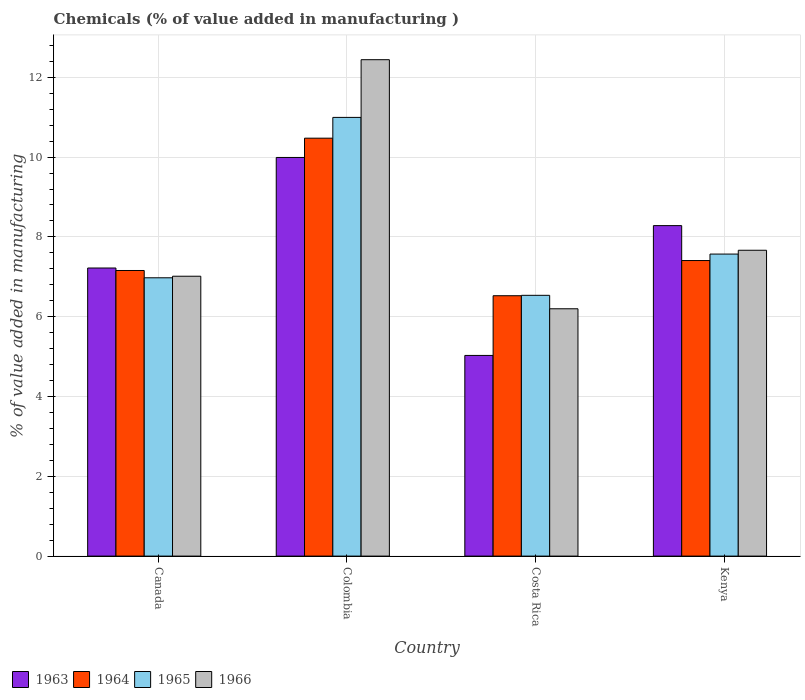How many groups of bars are there?
Provide a short and direct response. 4. Are the number of bars on each tick of the X-axis equal?
Your answer should be compact. Yes. How many bars are there on the 1st tick from the left?
Offer a terse response. 4. How many bars are there on the 1st tick from the right?
Your response must be concise. 4. What is the label of the 3rd group of bars from the left?
Provide a succinct answer. Costa Rica. What is the value added in manufacturing chemicals in 1963 in Canada?
Give a very brief answer. 7.22. Across all countries, what is the maximum value added in manufacturing chemicals in 1966?
Your answer should be very brief. 12.44. Across all countries, what is the minimum value added in manufacturing chemicals in 1963?
Provide a succinct answer. 5.03. In which country was the value added in manufacturing chemicals in 1963 minimum?
Make the answer very short. Costa Rica. What is the total value added in manufacturing chemicals in 1965 in the graph?
Provide a succinct answer. 32.08. What is the difference between the value added in manufacturing chemicals in 1963 in Costa Rica and that in Kenya?
Offer a very short reply. -3.25. What is the difference between the value added in manufacturing chemicals in 1963 in Kenya and the value added in manufacturing chemicals in 1964 in Colombia?
Make the answer very short. -2.19. What is the average value added in manufacturing chemicals in 1963 per country?
Keep it short and to the point. 7.63. What is the difference between the value added in manufacturing chemicals of/in 1963 and value added in manufacturing chemicals of/in 1965 in Kenya?
Provide a succinct answer. 0.71. In how many countries, is the value added in manufacturing chemicals in 1966 greater than 6.4 %?
Offer a terse response. 3. What is the ratio of the value added in manufacturing chemicals in 1963 in Costa Rica to that in Kenya?
Ensure brevity in your answer.  0.61. Is the value added in manufacturing chemicals in 1965 in Costa Rica less than that in Kenya?
Make the answer very short. Yes. What is the difference between the highest and the second highest value added in manufacturing chemicals in 1964?
Provide a succinct answer. 3.32. What is the difference between the highest and the lowest value added in manufacturing chemicals in 1965?
Make the answer very short. 4.46. Is the sum of the value added in manufacturing chemicals in 1965 in Colombia and Costa Rica greater than the maximum value added in manufacturing chemicals in 1964 across all countries?
Offer a very short reply. Yes. What does the 2nd bar from the left in Colombia represents?
Provide a short and direct response. 1964. What does the 1st bar from the right in Colombia represents?
Offer a very short reply. 1966. Is it the case that in every country, the sum of the value added in manufacturing chemicals in 1965 and value added in manufacturing chemicals in 1964 is greater than the value added in manufacturing chemicals in 1966?
Your answer should be very brief. Yes. Are all the bars in the graph horizontal?
Provide a succinct answer. No. What is the difference between two consecutive major ticks on the Y-axis?
Make the answer very short. 2. Does the graph contain any zero values?
Your response must be concise. No. Does the graph contain grids?
Your answer should be compact. Yes. How many legend labels are there?
Ensure brevity in your answer.  4. What is the title of the graph?
Ensure brevity in your answer.  Chemicals (% of value added in manufacturing ). What is the label or title of the X-axis?
Make the answer very short. Country. What is the label or title of the Y-axis?
Offer a very short reply. % of value added in manufacturing. What is the % of value added in manufacturing of 1963 in Canada?
Your answer should be very brief. 7.22. What is the % of value added in manufacturing in 1964 in Canada?
Your answer should be compact. 7.16. What is the % of value added in manufacturing in 1965 in Canada?
Your answer should be compact. 6.98. What is the % of value added in manufacturing of 1966 in Canada?
Keep it short and to the point. 7.01. What is the % of value added in manufacturing in 1963 in Colombia?
Provide a short and direct response. 9.99. What is the % of value added in manufacturing in 1964 in Colombia?
Ensure brevity in your answer.  10.47. What is the % of value added in manufacturing of 1965 in Colombia?
Offer a terse response. 10.99. What is the % of value added in manufacturing of 1966 in Colombia?
Give a very brief answer. 12.44. What is the % of value added in manufacturing in 1963 in Costa Rica?
Ensure brevity in your answer.  5.03. What is the % of value added in manufacturing in 1964 in Costa Rica?
Keep it short and to the point. 6.53. What is the % of value added in manufacturing of 1965 in Costa Rica?
Ensure brevity in your answer.  6.54. What is the % of value added in manufacturing in 1966 in Costa Rica?
Make the answer very short. 6.2. What is the % of value added in manufacturing in 1963 in Kenya?
Your answer should be compact. 8.28. What is the % of value added in manufacturing in 1964 in Kenya?
Your answer should be compact. 7.41. What is the % of value added in manufacturing in 1965 in Kenya?
Offer a terse response. 7.57. What is the % of value added in manufacturing of 1966 in Kenya?
Your response must be concise. 7.67. Across all countries, what is the maximum % of value added in manufacturing of 1963?
Make the answer very short. 9.99. Across all countries, what is the maximum % of value added in manufacturing of 1964?
Offer a terse response. 10.47. Across all countries, what is the maximum % of value added in manufacturing in 1965?
Ensure brevity in your answer.  10.99. Across all countries, what is the maximum % of value added in manufacturing in 1966?
Offer a very short reply. 12.44. Across all countries, what is the minimum % of value added in manufacturing of 1963?
Your answer should be very brief. 5.03. Across all countries, what is the minimum % of value added in manufacturing of 1964?
Offer a terse response. 6.53. Across all countries, what is the minimum % of value added in manufacturing in 1965?
Give a very brief answer. 6.54. Across all countries, what is the minimum % of value added in manufacturing of 1966?
Make the answer very short. 6.2. What is the total % of value added in manufacturing in 1963 in the graph?
Provide a succinct answer. 30.52. What is the total % of value added in manufacturing of 1964 in the graph?
Your answer should be very brief. 31.57. What is the total % of value added in manufacturing of 1965 in the graph?
Your answer should be compact. 32.08. What is the total % of value added in manufacturing of 1966 in the graph?
Make the answer very short. 33.32. What is the difference between the % of value added in manufacturing in 1963 in Canada and that in Colombia?
Offer a terse response. -2.77. What is the difference between the % of value added in manufacturing in 1964 in Canada and that in Colombia?
Give a very brief answer. -3.32. What is the difference between the % of value added in manufacturing of 1965 in Canada and that in Colombia?
Your answer should be compact. -4.02. What is the difference between the % of value added in manufacturing of 1966 in Canada and that in Colombia?
Provide a succinct answer. -5.43. What is the difference between the % of value added in manufacturing in 1963 in Canada and that in Costa Rica?
Make the answer very short. 2.19. What is the difference between the % of value added in manufacturing in 1964 in Canada and that in Costa Rica?
Give a very brief answer. 0.63. What is the difference between the % of value added in manufacturing of 1965 in Canada and that in Costa Rica?
Your answer should be very brief. 0.44. What is the difference between the % of value added in manufacturing of 1966 in Canada and that in Costa Rica?
Provide a succinct answer. 0.82. What is the difference between the % of value added in manufacturing of 1963 in Canada and that in Kenya?
Provide a short and direct response. -1.06. What is the difference between the % of value added in manufacturing in 1964 in Canada and that in Kenya?
Give a very brief answer. -0.25. What is the difference between the % of value added in manufacturing of 1965 in Canada and that in Kenya?
Offer a terse response. -0.59. What is the difference between the % of value added in manufacturing of 1966 in Canada and that in Kenya?
Keep it short and to the point. -0.65. What is the difference between the % of value added in manufacturing of 1963 in Colombia and that in Costa Rica?
Your response must be concise. 4.96. What is the difference between the % of value added in manufacturing in 1964 in Colombia and that in Costa Rica?
Your answer should be very brief. 3.95. What is the difference between the % of value added in manufacturing in 1965 in Colombia and that in Costa Rica?
Your answer should be very brief. 4.46. What is the difference between the % of value added in manufacturing of 1966 in Colombia and that in Costa Rica?
Provide a succinct answer. 6.24. What is the difference between the % of value added in manufacturing in 1963 in Colombia and that in Kenya?
Offer a terse response. 1.71. What is the difference between the % of value added in manufacturing in 1964 in Colombia and that in Kenya?
Your answer should be very brief. 3.07. What is the difference between the % of value added in manufacturing of 1965 in Colombia and that in Kenya?
Ensure brevity in your answer.  3.43. What is the difference between the % of value added in manufacturing of 1966 in Colombia and that in Kenya?
Provide a short and direct response. 4.78. What is the difference between the % of value added in manufacturing in 1963 in Costa Rica and that in Kenya?
Provide a succinct answer. -3.25. What is the difference between the % of value added in manufacturing of 1964 in Costa Rica and that in Kenya?
Ensure brevity in your answer.  -0.88. What is the difference between the % of value added in manufacturing in 1965 in Costa Rica and that in Kenya?
Give a very brief answer. -1.03. What is the difference between the % of value added in manufacturing of 1966 in Costa Rica and that in Kenya?
Your answer should be compact. -1.47. What is the difference between the % of value added in manufacturing in 1963 in Canada and the % of value added in manufacturing in 1964 in Colombia?
Provide a short and direct response. -3.25. What is the difference between the % of value added in manufacturing in 1963 in Canada and the % of value added in manufacturing in 1965 in Colombia?
Your response must be concise. -3.77. What is the difference between the % of value added in manufacturing of 1963 in Canada and the % of value added in manufacturing of 1966 in Colombia?
Keep it short and to the point. -5.22. What is the difference between the % of value added in manufacturing in 1964 in Canada and the % of value added in manufacturing in 1965 in Colombia?
Give a very brief answer. -3.84. What is the difference between the % of value added in manufacturing in 1964 in Canada and the % of value added in manufacturing in 1966 in Colombia?
Provide a succinct answer. -5.28. What is the difference between the % of value added in manufacturing in 1965 in Canada and the % of value added in manufacturing in 1966 in Colombia?
Provide a succinct answer. -5.47. What is the difference between the % of value added in manufacturing in 1963 in Canada and the % of value added in manufacturing in 1964 in Costa Rica?
Make the answer very short. 0.69. What is the difference between the % of value added in manufacturing of 1963 in Canada and the % of value added in manufacturing of 1965 in Costa Rica?
Provide a succinct answer. 0.68. What is the difference between the % of value added in manufacturing in 1963 in Canada and the % of value added in manufacturing in 1966 in Costa Rica?
Give a very brief answer. 1.02. What is the difference between the % of value added in manufacturing of 1964 in Canada and the % of value added in manufacturing of 1965 in Costa Rica?
Make the answer very short. 0.62. What is the difference between the % of value added in manufacturing of 1964 in Canada and the % of value added in manufacturing of 1966 in Costa Rica?
Your answer should be very brief. 0.96. What is the difference between the % of value added in manufacturing of 1965 in Canada and the % of value added in manufacturing of 1966 in Costa Rica?
Offer a terse response. 0.78. What is the difference between the % of value added in manufacturing in 1963 in Canada and the % of value added in manufacturing in 1964 in Kenya?
Keep it short and to the point. -0.19. What is the difference between the % of value added in manufacturing of 1963 in Canada and the % of value added in manufacturing of 1965 in Kenya?
Your response must be concise. -0.35. What is the difference between the % of value added in manufacturing in 1963 in Canada and the % of value added in manufacturing in 1966 in Kenya?
Keep it short and to the point. -0.44. What is the difference between the % of value added in manufacturing of 1964 in Canada and the % of value added in manufacturing of 1965 in Kenya?
Offer a terse response. -0.41. What is the difference between the % of value added in manufacturing of 1964 in Canada and the % of value added in manufacturing of 1966 in Kenya?
Your response must be concise. -0.51. What is the difference between the % of value added in manufacturing in 1965 in Canada and the % of value added in manufacturing in 1966 in Kenya?
Your answer should be compact. -0.69. What is the difference between the % of value added in manufacturing of 1963 in Colombia and the % of value added in manufacturing of 1964 in Costa Rica?
Your answer should be compact. 3.47. What is the difference between the % of value added in manufacturing of 1963 in Colombia and the % of value added in manufacturing of 1965 in Costa Rica?
Your response must be concise. 3.46. What is the difference between the % of value added in manufacturing in 1963 in Colombia and the % of value added in manufacturing in 1966 in Costa Rica?
Your response must be concise. 3.79. What is the difference between the % of value added in manufacturing of 1964 in Colombia and the % of value added in manufacturing of 1965 in Costa Rica?
Offer a very short reply. 3.94. What is the difference between the % of value added in manufacturing in 1964 in Colombia and the % of value added in manufacturing in 1966 in Costa Rica?
Your answer should be very brief. 4.28. What is the difference between the % of value added in manufacturing in 1965 in Colombia and the % of value added in manufacturing in 1966 in Costa Rica?
Provide a short and direct response. 4.8. What is the difference between the % of value added in manufacturing in 1963 in Colombia and the % of value added in manufacturing in 1964 in Kenya?
Keep it short and to the point. 2.58. What is the difference between the % of value added in manufacturing in 1963 in Colombia and the % of value added in manufacturing in 1965 in Kenya?
Your answer should be compact. 2.42. What is the difference between the % of value added in manufacturing in 1963 in Colombia and the % of value added in manufacturing in 1966 in Kenya?
Offer a terse response. 2.33. What is the difference between the % of value added in manufacturing of 1964 in Colombia and the % of value added in manufacturing of 1965 in Kenya?
Your response must be concise. 2.9. What is the difference between the % of value added in manufacturing of 1964 in Colombia and the % of value added in manufacturing of 1966 in Kenya?
Provide a succinct answer. 2.81. What is the difference between the % of value added in manufacturing in 1965 in Colombia and the % of value added in manufacturing in 1966 in Kenya?
Your answer should be compact. 3.33. What is the difference between the % of value added in manufacturing of 1963 in Costa Rica and the % of value added in manufacturing of 1964 in Kenya?
Keep it short and to the point. -2.38. What is the difference between the % of value added in manufacturing of 1963 in Costa Rica and the % of value added in manufacturing of 1965 in Kenya?
Provide a succinct answer. -2.54. What is the difference between the % of value added in manufacturing in 1963 in Costa Rica and the % of value added in manufacturing in 1966 in Kenya?
Your answer should be compact. -2.64. What is the difference between the % of value added in manufacturing of 1964 in Costa Rica and the % of value added in manufacturing of 1965 in Kenya?
Your answer should be very brief. -1.04. What is the difference between the % of value added in manufacturing of 1964 in Costa Rica and the % of value added in manufacturing of 1966 in Kenya?
Provide a succinct answer. -1.14. What is the difference between the % of value added in manufacturing in 1965 in Costa Rica and the % of value added in manufacturing in 1966 in Kenya?
Keep it short and to the point. -1.13. What is the average % of value added in manufacturing of 1963 per country?
Provide a succinct answer. 7.63. What is the average % of value added in manufacturing in 1964 per country?
Provide a short and direct response. 7.89. What is the average % of value added in manufacturing in 1965 per country?
Offer a terse response. 8.02. What is the average % of value added in manufacturing of 1966 per country?
Your answer should be very brief. 8.33. What is the difference between the % of value added in manufacturing of 1963 and % of value added in manufacturing of 1964 in Canada?
Ensure brevity in your answer.  0.06. What is the difference between the % of value added in manufacturing in 1963 and % of value added in manufacturing in 1965 in Canada?
Give a very brief answer. 0.25. What is the difference between the % of value added in manufacturing in 1963 and % of value added in manufacturing in 1966 in Canada?
Keep it short and to the point. 0.21. What is the difference between the % of value added in manufacturing in 1964 and % of value added in manufacturing in 1965 in Canada?
Ensure brevity in your answer.  0.18. What is the difference between the % of value added in manufacturing of 1964 and % of value added in manufacturing of 1966 in Canada?
Offer a very short reply. 0.14. What is the difference between the % of value added in manufacturing in 1965 and % of value added in manufacturing in 1966 in Canada?
Your answer should be very brief. -0.04. What is the difference between the % of value added in manufacturing in 1963 and % of value added in manufacturing in 1964 in Colombia?
Provide a short and direct response. -0.48. What is the difference between the % of value added in manufacturing in 1963 and % of value added in manufacturing in 1965 in Colombia?
Make the answer very short. -1. What is the difference between the % of value added in manufacturing of 1963 and % of value added in manufacturing of 1966 in Colombia?
Provide a short and direct response. -2.45. What is the difference between the % of value added in manufacturing in 1964 and % of value added in manufacturing in 1965 in Colombia?
Ensure brevity in your answer.  -0.52. What is the difference between the % of value added in manufacturing of 1964 and % of value added in manufacturing of 1966 in Colombia?
Give a very brief answer. -1.97. What is the difference between the % of value added in manufacturing in 1965 and % of value added in manufacturing in 1966 in Colombia?
Keep it short and to the point. -1.45. What is the difference between the % of value added in manufacturing of 1963 and % of value added in manufacturing of 1964 in Costa Rica?
Your response must be concise. -1.5. What is the difference between the % of value added in manufacturing of 1963 and % of value added in manufacturing of 1965 in Costa Rica?
Give a very brief answer. -1.51. What is the difference between the % of value added in manufacturing of 1963 and % of value added in manufacturing of 1966 in Costa Rica?
Give a very brief answer. -1.17. What is the difference between the % of value added in manufacturing of 1964 and % of value added in manufacturing of 1965 in Costa Rica?
Keep it short and to the point. -0.01. What is the difference between the % of value added in manufacturing in 1964 and % of value added in manufacturing in 1966 in Costa Rica?
Make the answer very short. 0.33. What is the difference between the % of value added in manufacturing in 1965 and % of value added in manufacturing in 1966 in Costa Rica?
Ensure brevity in your answer.  0.34. What is the difference between the % of value added in manufacturing of 1963 and % of value added in manufacturing of 1964 in Kenya?
Offer a very short reply. 0.87. What is the difference between the % of value added in manufacturing in 1963 and % of value added in manufacturing in 1965 in Kenya?
Offer a very short reply. 0.71. What is the difference between the % of value added in manufacturing of 1963 and % of value added in manufacturing of 1966 in Kenya?
Your response must be concise. 0.62. What is the difference between the % of value added in manufacturing in 1964 and % of value added in manufacturing in 1965 in Kenya?
Keep it short and to the point. -0.16. What is the difference between the % of value added in manufacturing of 1964 and % of value added in manufacturing of 1966 in Kenya?
Give a very brief answer. -0.26. What is the difference between the % of value added in manufacturing in 1965 and % of value added in manufacturing in 1966 in Kenya?
Make the answer very short. -0.1. What is the ratio of the % of value added in manufacturing in 1963 in Canada to that in Colombia?
Ensure brevity in your answer.  0.72. What is the ratio of the % of value added in manufacturing in 1964 in Canada to that in Colombia?
Provide a succinct answer. 0.68. What is the ratio of the % of value added in manufacturing in 1965 in Canada to that in Colombia?
Your answer should be very brief. 0.63. What is the ratio of the % of value added in manufacturing in 1966 in Canada to that in Colombia?
Your answer should be very brief. 0.56. What is the ratio of the % of value added in manufacturing in 1963 in Canada to that in Costa Rica?
Your answer should be compact. 1.44. What is the ratio of the % of value added in manufacturing of 1964 in Canada to that in Costa Rica?
Your answer should be very brief. 1.1. What is the ratio of the % of value added in manufacturing of 1965 in Canada to that in Costa Rica?
Your answer should be compact. 1.07. What is the ratio of the % of value added in manufacturing in 1966 in Canada to that in Costa Rica?
Your response must be concise. 1.13. What is the ratio of the % of value added in manufacturing in 1963 in Canada to that in Kenya?
Your answer should be compact. 0.87. What is the ratio of the % of value added in manufacturing of 1964 in Canada to that in Kenya?
Provide a succinct answer. 0.97. What is the ratio of the % of value added in manufacturing of 1965 in Canada to that in Kenya?
Ensure brevity in your answer.  0.92. What is the ratio of the % of value added in manufacturing in 1966 in Canada to that in Kenya?
Keep it short and to the point. 0.92. What is the ratio of the % of value added in manufacturing of 1963 in Colombia to that in Costa Rica?
Offer a very short reply. 1.99. What is the ratio of the % of value added in manufacturing of 1964 in Colombia to that in Costa Rica?
Offer a terse response. 1.61. What is the ratio of the % of value added in manufacturing in 1965 in Colombia to that in Costa Rica?
Offer a terse response. 1.68. What is the ratio of the % of value added in manufacturing of 1966 in Colombia to that in Costa Rica?
Ensure brevity in your answer.  2.01. What is the ratio of the % of value added in manufacturing in 1963 in Colombia to that in Kenya?
Offer a terse response. 1.21. What is the ratio of the % of value added in manufacturing in 1964 in Colombia to that in Kenya?
Offer a terse response. 1.41. What is the ratio of the % of value added in manufacturing in 1965 in Colombia to that in Kenya?
Your answer should be very brief. 1.45. What is the ratio of the % of value added in manufacturing in 1966 in Colombia to that in Kenya?
Give a very brief answer. 1.62. What is the ratio of the % of value added in manufacturing in 1963 in Costa Rica to that in Kenya?
Your answer should be very brief. 0.61. What is the ratio of the % of value added in manufacturing of 1964 in Costa Rica to that in Kenya?
Keep it short and to the point. 0.88. What is the ratio of the % of value added in manufacturing of 1965 in Costa Rica to that in Kenya?
Provide a short and direct response. 0.86. What is the ratio of the % of value added in manufacturing in 1966 in Costa Rica to that in Kenya?
Your response must be concise. 0.81. What is the difference between the highest and the second highest % of value added in manufacturing of 1963?
Provide a short and direct response. 1.71. What is the difference between the highest and the second highest % of value added in manufacturing in 1964?
Offer a terse response. 3.07. What is the difference between the highest and the second highest % of value added in manufacturing in 1965?
Make the answer very short. 3.43. What is the difference between the highest and the second highest % of value added in manufacturing in 1966?
Offer a very short reply. 4.78. What is the difference between the highest and the lowest % of value added in manufacturing in 1963?
Make the answer very short. 4.96. What is the difference between the highest and the lowest % of value added in manufacturing of 1964?
Your answer should be very brief. 3.95. What is the difference between the highest and the lowest % of value added in manufacturing of 1965?
Offer a very short reply. 4.46. What is the difference between the highest and the lowest % of value added in manufacturing in 1966?
Offer a terse response. 6.24. 